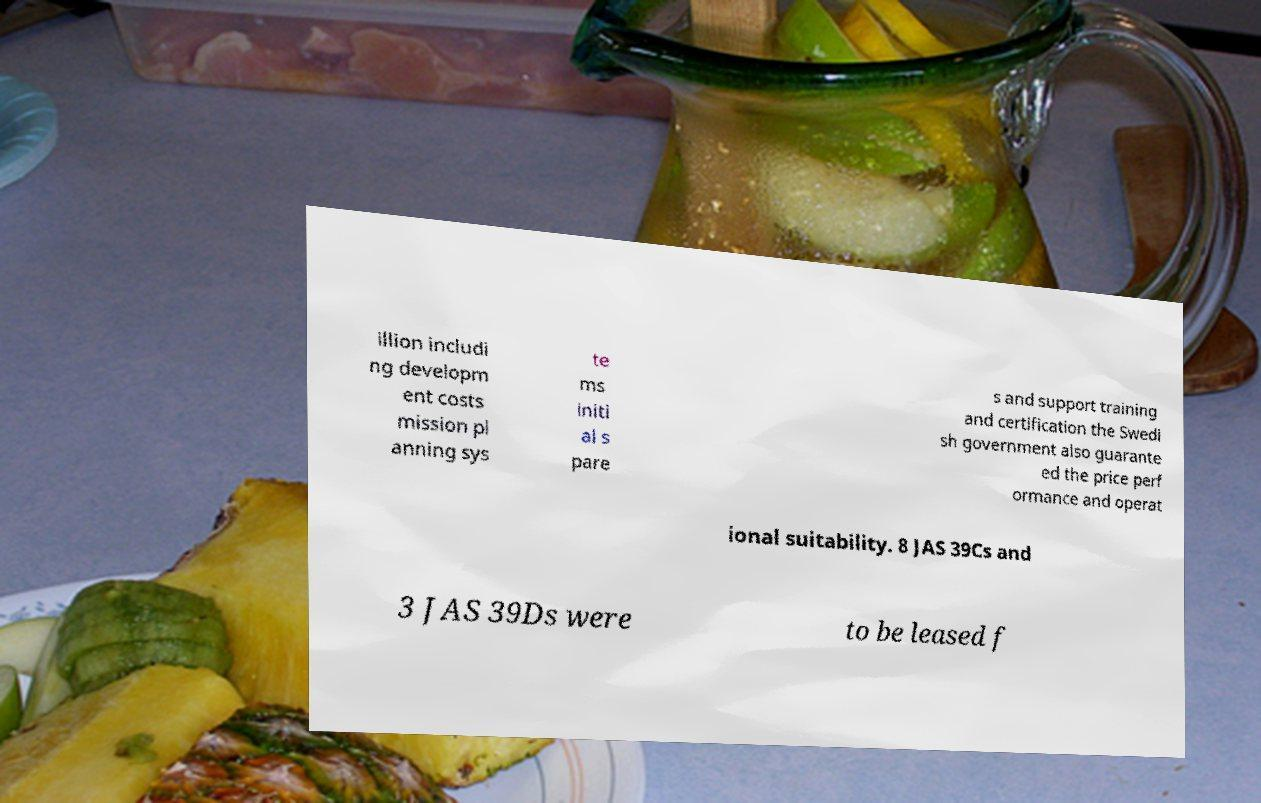I need the written content from this picture converted into text. Can you do that? illion includi ng developm ent costs mission pl anning sys te ms initi al s pare s and support training and certification the Swedi sh government also guarante ed the price perf ormance and operat ional suitability. 8 JAS 39Cs and 3 JAS 39Ds were to be leased f 